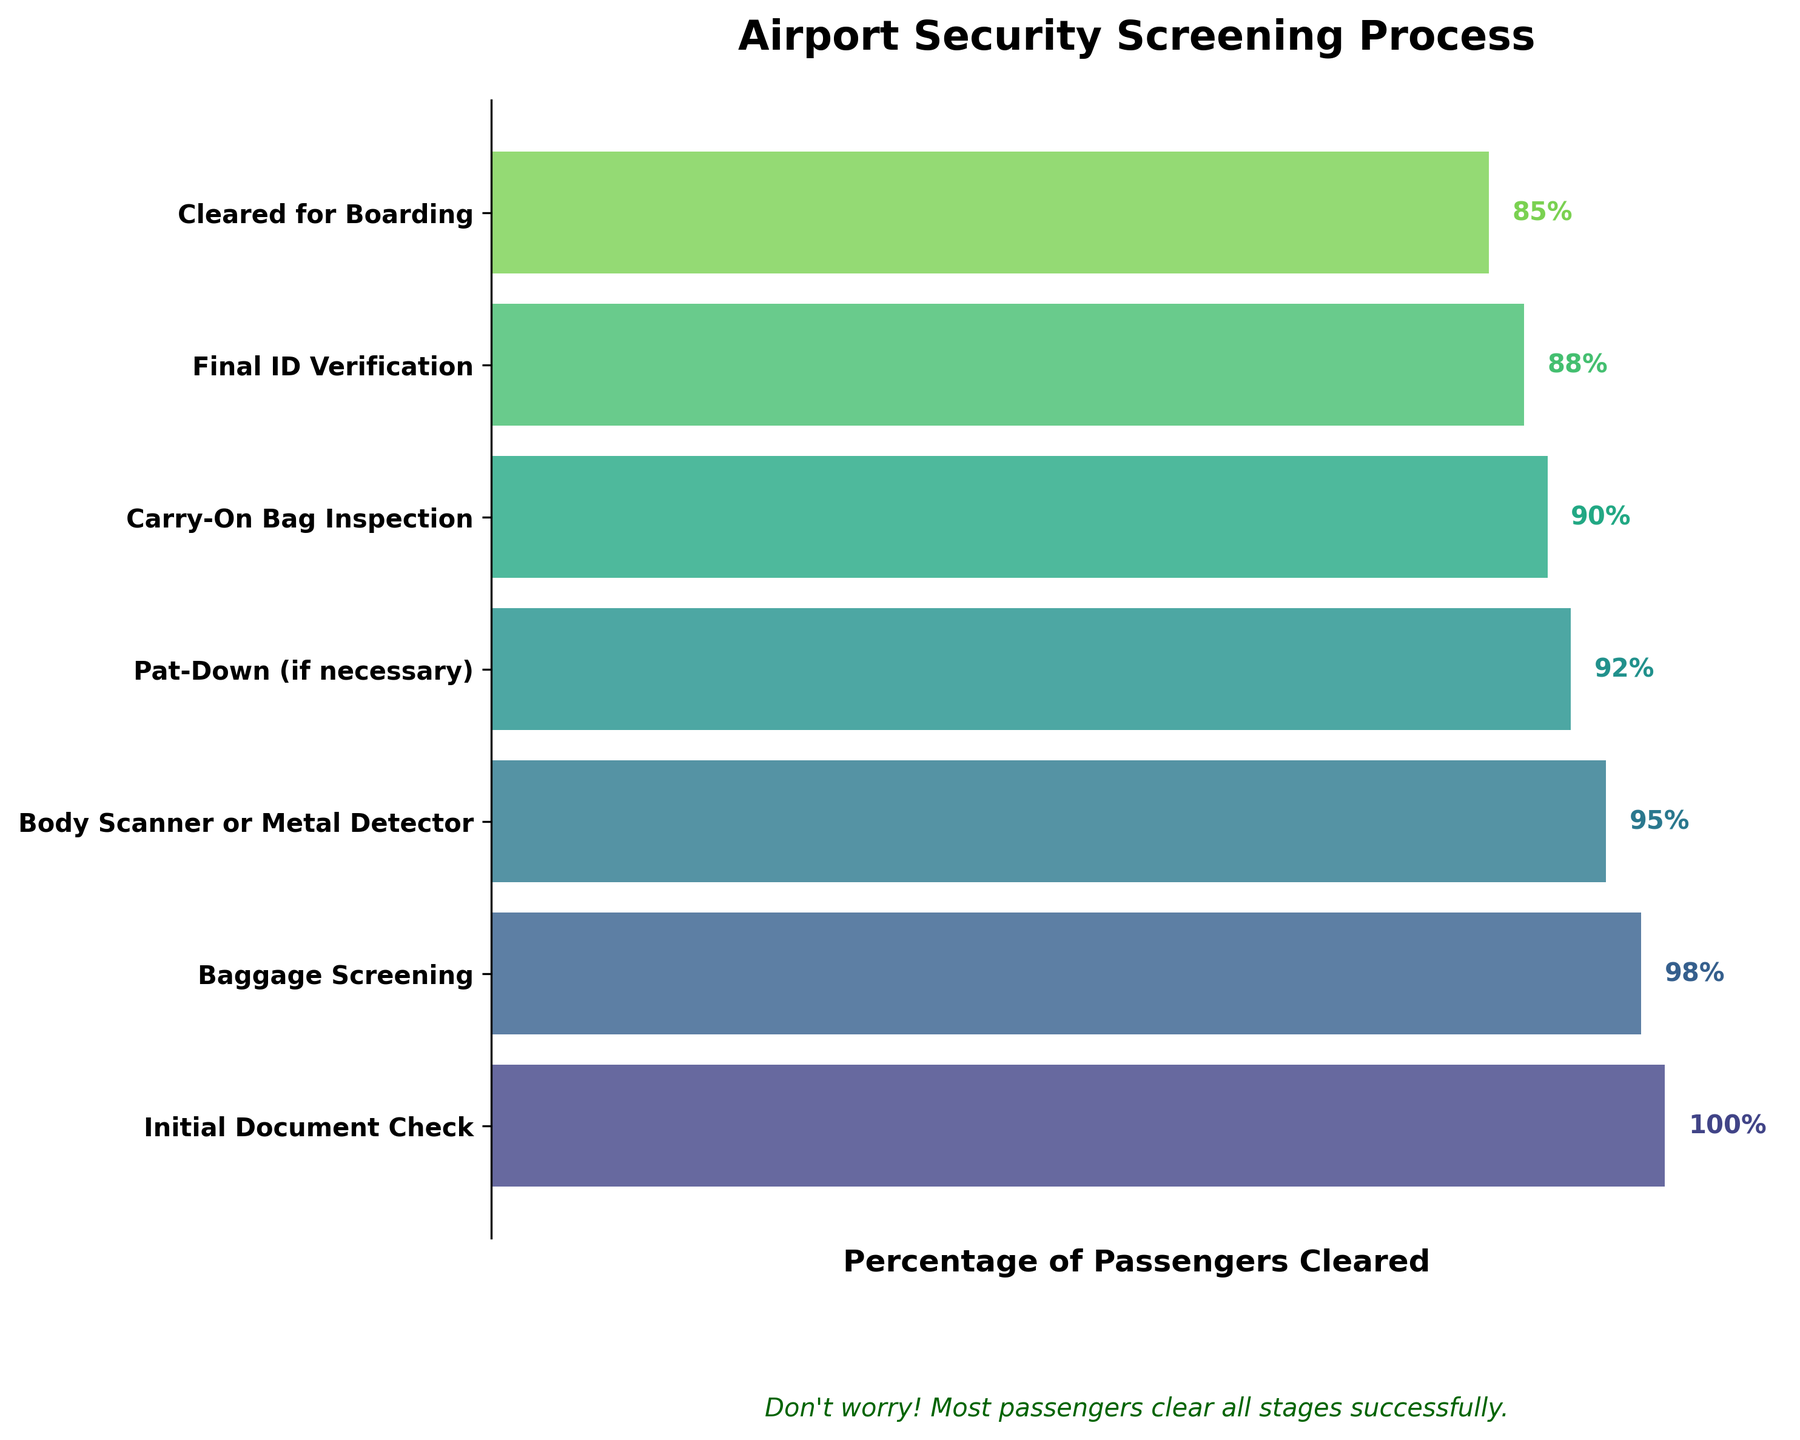What's the title of the chart? The title is usually displayed at the top of the chart. According to the provided code, it is "Airport Security Screening Process."
Answer: Airport Security Screening Process How many stages are depicted in the chart? The chart shows a funnel with multiple levels, each representing a different stage of the screening process. By counting these levels, you can see there are 7 stages.
Answer: 7 What percentage of passengers are cleared after the initial document check? The percentage is displayed directly on the chart next to the "Initial Document Check" stage. It is 100%.
Answer: 100% Which stage has the lowest clearance percentage? By looking at the funnel from top to bottom, the smallest percentage shown is 85% at the "Cleared for Boarding" stage.
Answer: Cleared for Boarding What is the difference in percentage between the Baggage Screening and Pat-Down stages? The Baggage Screening stage shows 98% and the Pat-Down stage shows 92%. The difference between these percentages is 98% - 92% = 6%.
Answer: 6% How many stages have a clearance rate above 90%? By examining the percentages listed next to each stage, we see the stages with percentages greater than 90% are the Initial Document Check (100%), Baggage Screening (98%), Body Scanner or Metal Detector (95%), and Pat-Down (92%). So, there are 4 stages.
Answer: 4 At which stage does the clearance rate drop below 90% for the first time? By following the sequence of stages from top to bottom, the first stage where the percentage drops below 90% is the "Carry-On Bag Inspection" stage with an 90% clearance rate.
Answer: Carry-On Bag Inspection What is the average clearance rate across all stages? To calculate the average, add all the percentages and divide by the number of stages: (100 + 98 + 95 + 92 + 90 + 88 + 85) / 7 = 92.57%.
Answer: 92.57% Is there any stage where the clearance rate drops by 10% or more compared to the previous stage? By looking at the percentage drops between each consecutive stage, we note the changes: 100% to 98% (2%), 98% to 95% (3%), 95% to 92% (3%), 92% to 90% (2%), 90% to 88% (2%), and 88% to 85% (3%). None of these drops are 10% or more.
Answer: No According to the chart, what message is included to reassure anxious passengers? At the bottom of the chart under the plot area, there is a text that says: "Don't worry! Most passengers clear all stages successfully."
Answer: Don't worry! Most passengers clear all stages successfully 